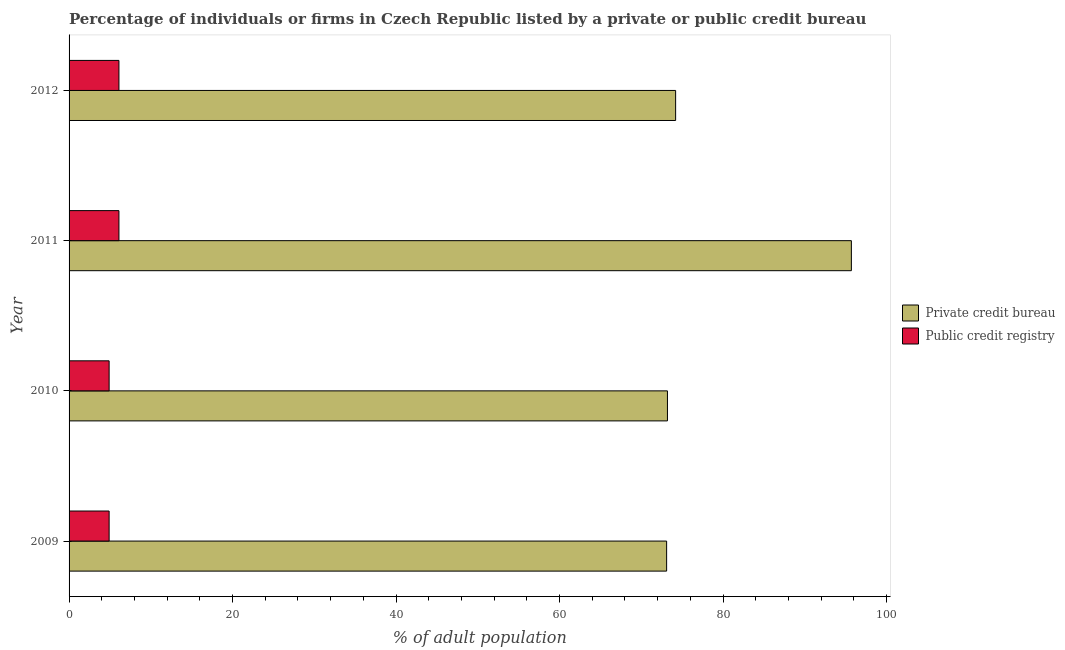How many different coloured bars are there?
Give a very brief answer. 2. How many groups of bars are there?
Keep it short and to the point. 4. Are the number of bars on each tick of the Y-axis equal?
Offer a terse response. Yes. How many bars are there on the 4th tick from the top?
Give a very brief answer. 2. How many bars are there on the 2nd tick from the bottom?
Ensure brevity in your answer.  2. What is the label of the 4th group of bars from the top?
Ensure brevity in your answer.  2009. What is the percentage of firms listed by public credit bureau in 2009?
Make the answer very short. 4.9. Across all years, what is the maximum percentage of firms listed by public credit bureau?
Your answer should be compact. 6.1. What is the difference between the percentage of firms listed by public credit bureau in 2011 and that in 2012?
Your answer should be compact. 0. What is the difference between the percentage of firms listed by private credit bureau in 2011 and the percentage of firms listed by public credit bureau in 2010?
Offer a terse response. 90.8. What is the average percentage of firms listed by private credit bureau per year?
Offer a very short reply. 79.05. In the year 2009, what is the difference between the percentage of firms listed by public credit bureau and percentage of firms listed by private credit bureau?
Give a very brief answer. -68.2. In how many years, is the percentage of firms listed by public credit bureau greater than 84 %?
Ensure brevity in your answer.  0. Is the percentage of firms listed by public credit bureau in 2011 less than that in 2012?
Your answer should be compact. No. What is the difference between the highest and the second highest percentage of firms listed by public credit bureau?
Your answer should be compact. 0. What is the difference between the highest and the lowest percentage of firms listed by public credit bureau?
Give a very brief answer. 1.2. What does the 1st bar from the top in 2011 represents?
Make the answer very short. Public credit registry. What does the 1st bar from the bottom in 2012 represents?
Make the answer very short. Private credit bureau. What is the difference between two consecutive major ticks on the X-axis?
Your answer should be compact. 20. Are the values on the major ticks of X-axis written in scientific E-notation?
Your answer should be very brief. No. Where does the legend appear in the graph?
Provide a short and direct response. Center right. How many legend labels are there?
Provide a succinct answer. 2. How are the legend labels stacked?
Your response must be concise. Vertical. What is the title of the graph?
Your answer should be compact. Percentage of individuals or firms in Czech Republic listed by a private or public credit bureau. What is the label or title of the X-axis?
Keep it short and to the point. % of adult population. What is the % of adult population of Private credit bureau in 2009?
Your response must be concise. 73.1. What is the % of adult population of Public credit registry in 2009?
Your answer should be compact. 4.9. What is the % of adult population in Private credit bureau in 2010?
Your response must be concise. 73.2. What is the % of adult population in Public credit registry in 2010?
Your answer should be compact. 4.9. What is the % of adult population of Private credit bureau in 2011?
Offer a very short reply. 95.7. What is the % of adult population of Public credit registry in 2011?
Ensure brevity in your answer.  6.1. What is the % of adult population in Private credit bureau in 2012?
Offer a very short reply. 74.2. What is the % of adult population in Public credit registry in 2012?
Offer a terse response. 6.1. Across all years, what is the maximum % of adult population of Private credit bureau?
Your answer should be compact. 95.7. Across all years, what is the maximum % of adult population of Public credit registry?
Your answer should be compact. 6.1. Across all years, what is the minimum % of adult population of Private credit bureau?
Offer a very short reply. 73.1. Across all years, what is the minimum % of adult population of Public credit registry?
Ensure brevity in your answer.  4.9. What is the total % of adult population of Private credit bureau in the graph?
Make the answer very short. 316.2. What is the difference between the % of adult population of Public credit registry in 2009 and that in 2010?
Your answer should be compact. 0. What is the difference between the % of adult population in Private credit bureau in 2009 and that in 2011?
Provide a succinct answer. -22.6. What is the difference between the % of adult population in Private credit bureau in 2010 and that in 2011?
Offer a terse response. -22.5. What is the difference between the % of adult population of Private credit bureau in 2011 and that in 2012?
Provide a short and direct response. 21.5. What is the difference between the % of adult population of Private credit bureau in 2009 and the % of adult population of Public credit registry in 2010?
Your answer should be very brief. 68.2. What is the difference between the % of adult population of Private credit bureau in 2009 and the % of adult population of Public credit registry in 2011?
Offer a very short reply. 67. What is the difference between the % of adult population in Private credit bureau in 2009 and the % of adult population in Public credit registry in 2012?
Make the answer very short. 67. What is the difference between the % of adult population in Private credit bureau in 2010 and the % of adult population in Public credit registry in 2011?
Your answer should be very brief. 67.1. What is the difference between the % of adult population in Private credit bureau in 2010 and the % of adult population in Public credit registry in 2012?
Keep it short and to the point. 67.1. What is the difference between the % of adult population in Private credit bureau in 2011 and the % of adult population in Public credit registry in 2012?
Provide a succinct answer. 89.6. What is the average % of adult population of Private credit bureau per year?
Provide a short and direct response. 79.05. In the year 2009, what is the difference between the % of adult population in Private credit bureau and % of adult population in Public credit registry?
Make the answer very short. 68.2. In the year 2010, what is the difference between the % of adult population of Private credit bureau and % of adult population of Public credit registry?
Make the answer very short. 68.3. In the year 2011, what is the difference between the % of adult population of Private credit bureau and % of adult population of Public credit registry?
Ensure brevity in your answer.  89.6. In the year 2012, what is the difference between the % of adult population of Private credit bureau and % of adult population of Public credit registry?
Give a very brief answer. 68.1. What is the ratio of the % of adult population of Private credit bureau in 2009 to that in 2011?
Your response must be concise. 0.76. What is the ratio of the % of adult population of Public credit registry in 2009 to that in 2011?
Offer a terse response. 0.8. What is the ratio of the % of adult population of Private credit bureau in 2009 to that in 2012?
Offer a very short reply. 0.99. What is the ratio of the % of adult population of Public credit registry in 2009 to that in 2012?
Your answer should be very brief. 0.8. What is the ratio of the % of adult population of Private credit bureau in 2010 to that in 2011?
Offer a terse response. 0.76. What is the ratio of the % of adult population of Public credit registry in 2010 to that in 2011?
Ensure brevity in your answer.  0.8. What is the ratio of the % of adult population of Private credit bureau in 2010 to that in 2012?
Keep it short and to the point. 0.99. What is the ratio of the % of adult population of Public credit registry in 2010 to that in 2012?
Provide a short and direct response. 0.8. What is the ratio of the % of adult population of Private credit bureau in 2011 to that in 2012?
Give a very brief answer. 1.29. What is the ratio of the % of adult population of Public credit registry in 2011 to that in 2012?
Provide a short and direct response. 1. What is the difference between the highest and the second highest % of adult population of Private credit bureau?
Give a very brief answer. 21.5. What is the difference between the highest and the lowest % of adult population of Private credit bureau?
Provide a short and direct response. 22.6. 